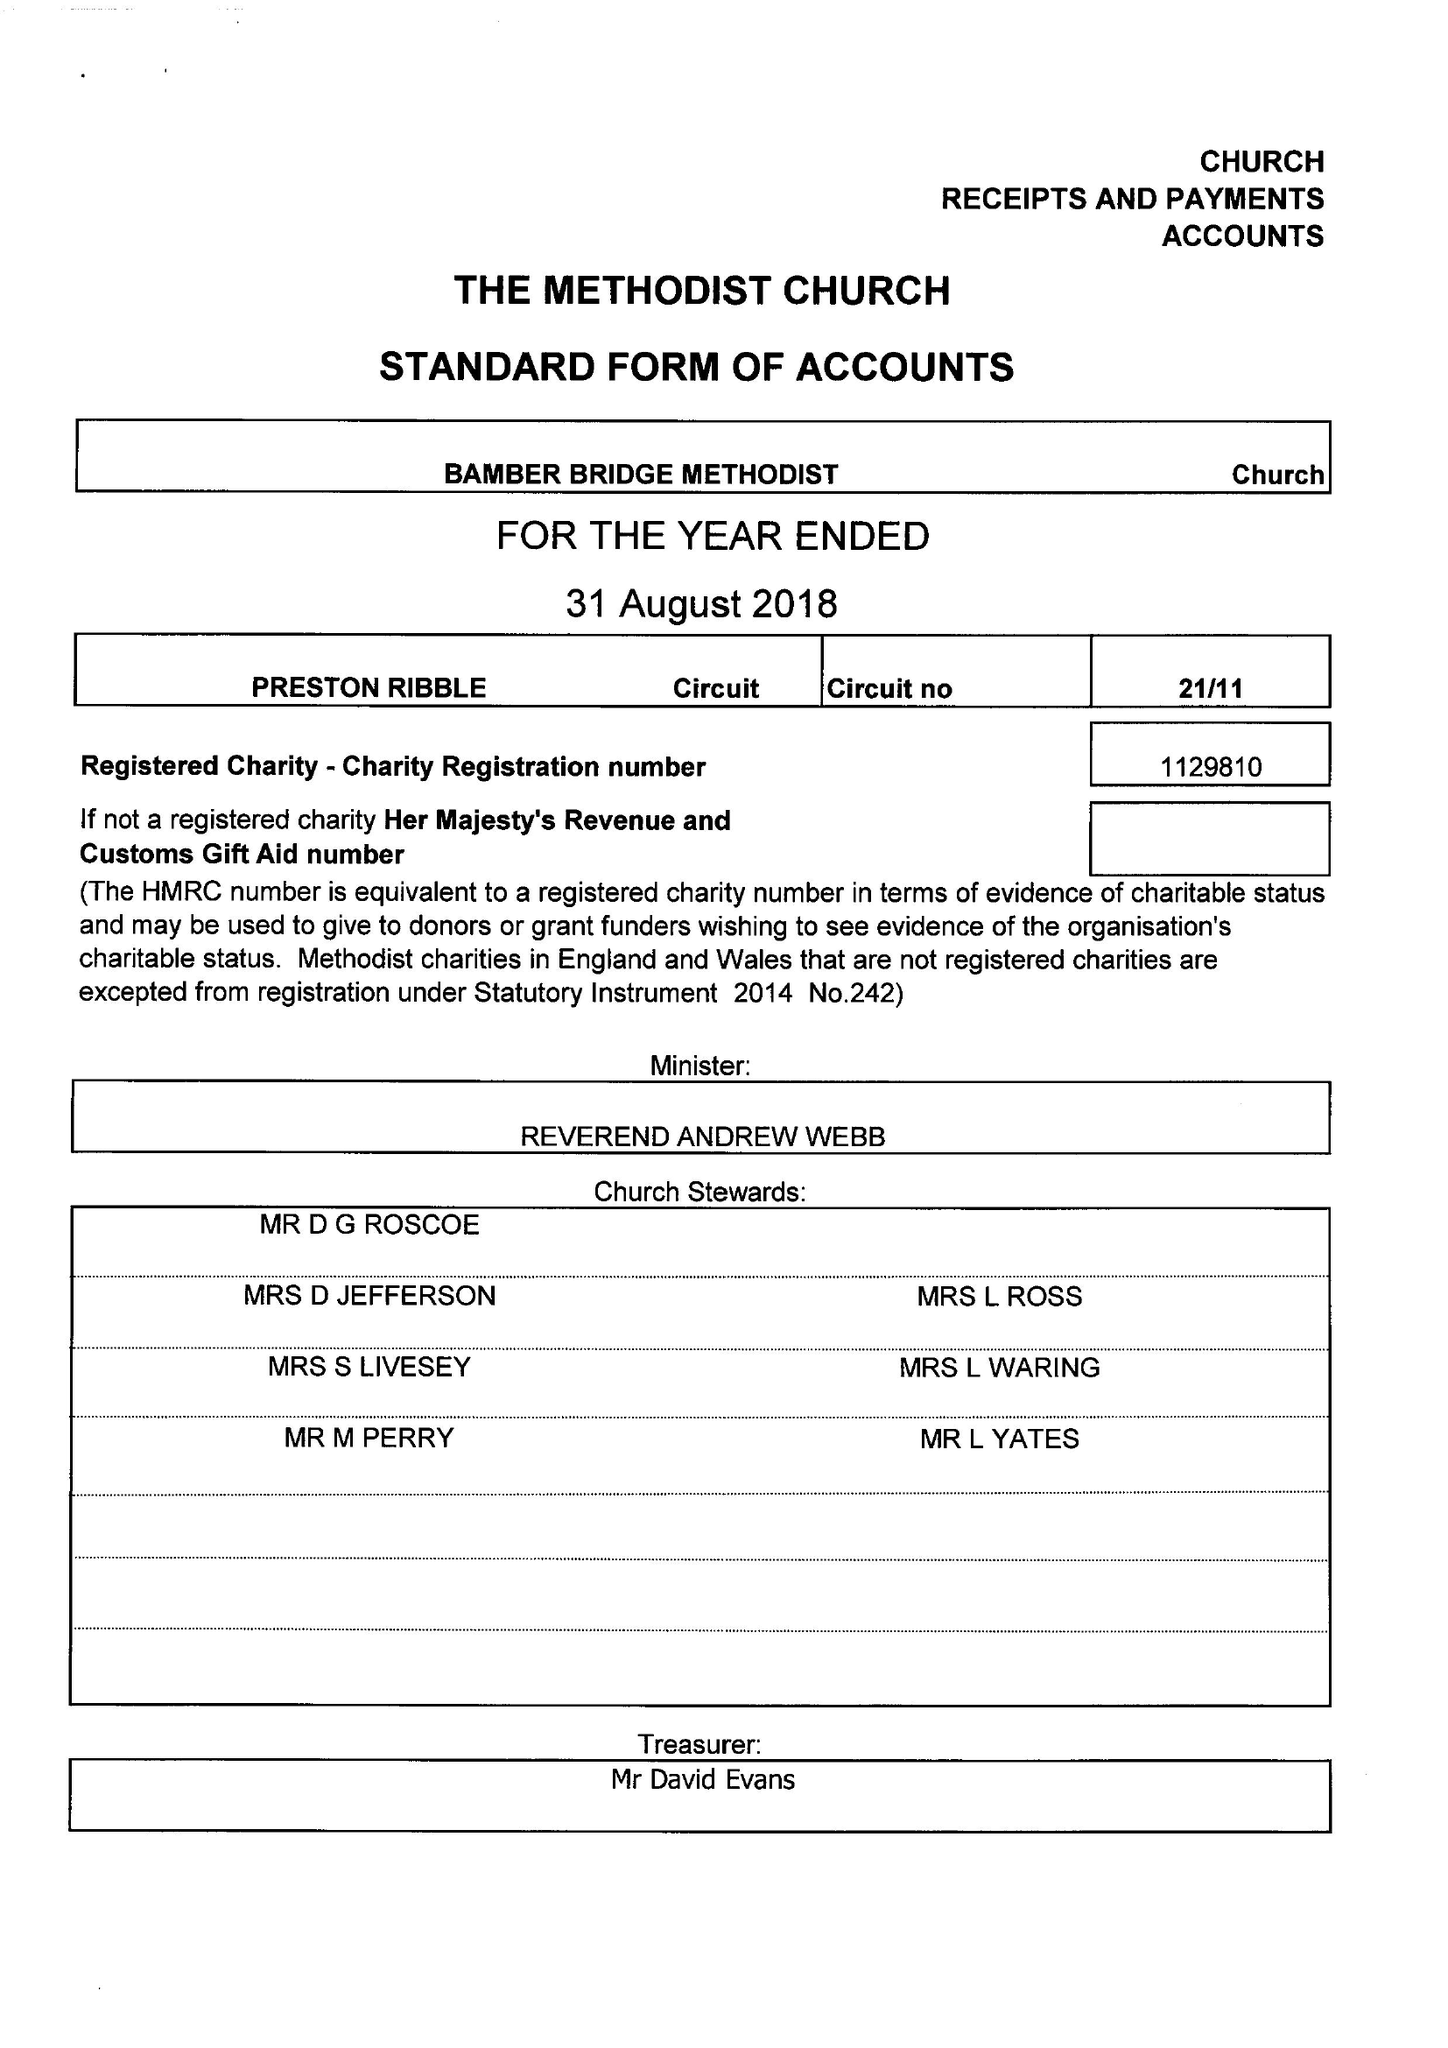What is the value for the address__street_line?
Answer the question using a single word or phrase. 1 EDWARD STREET 